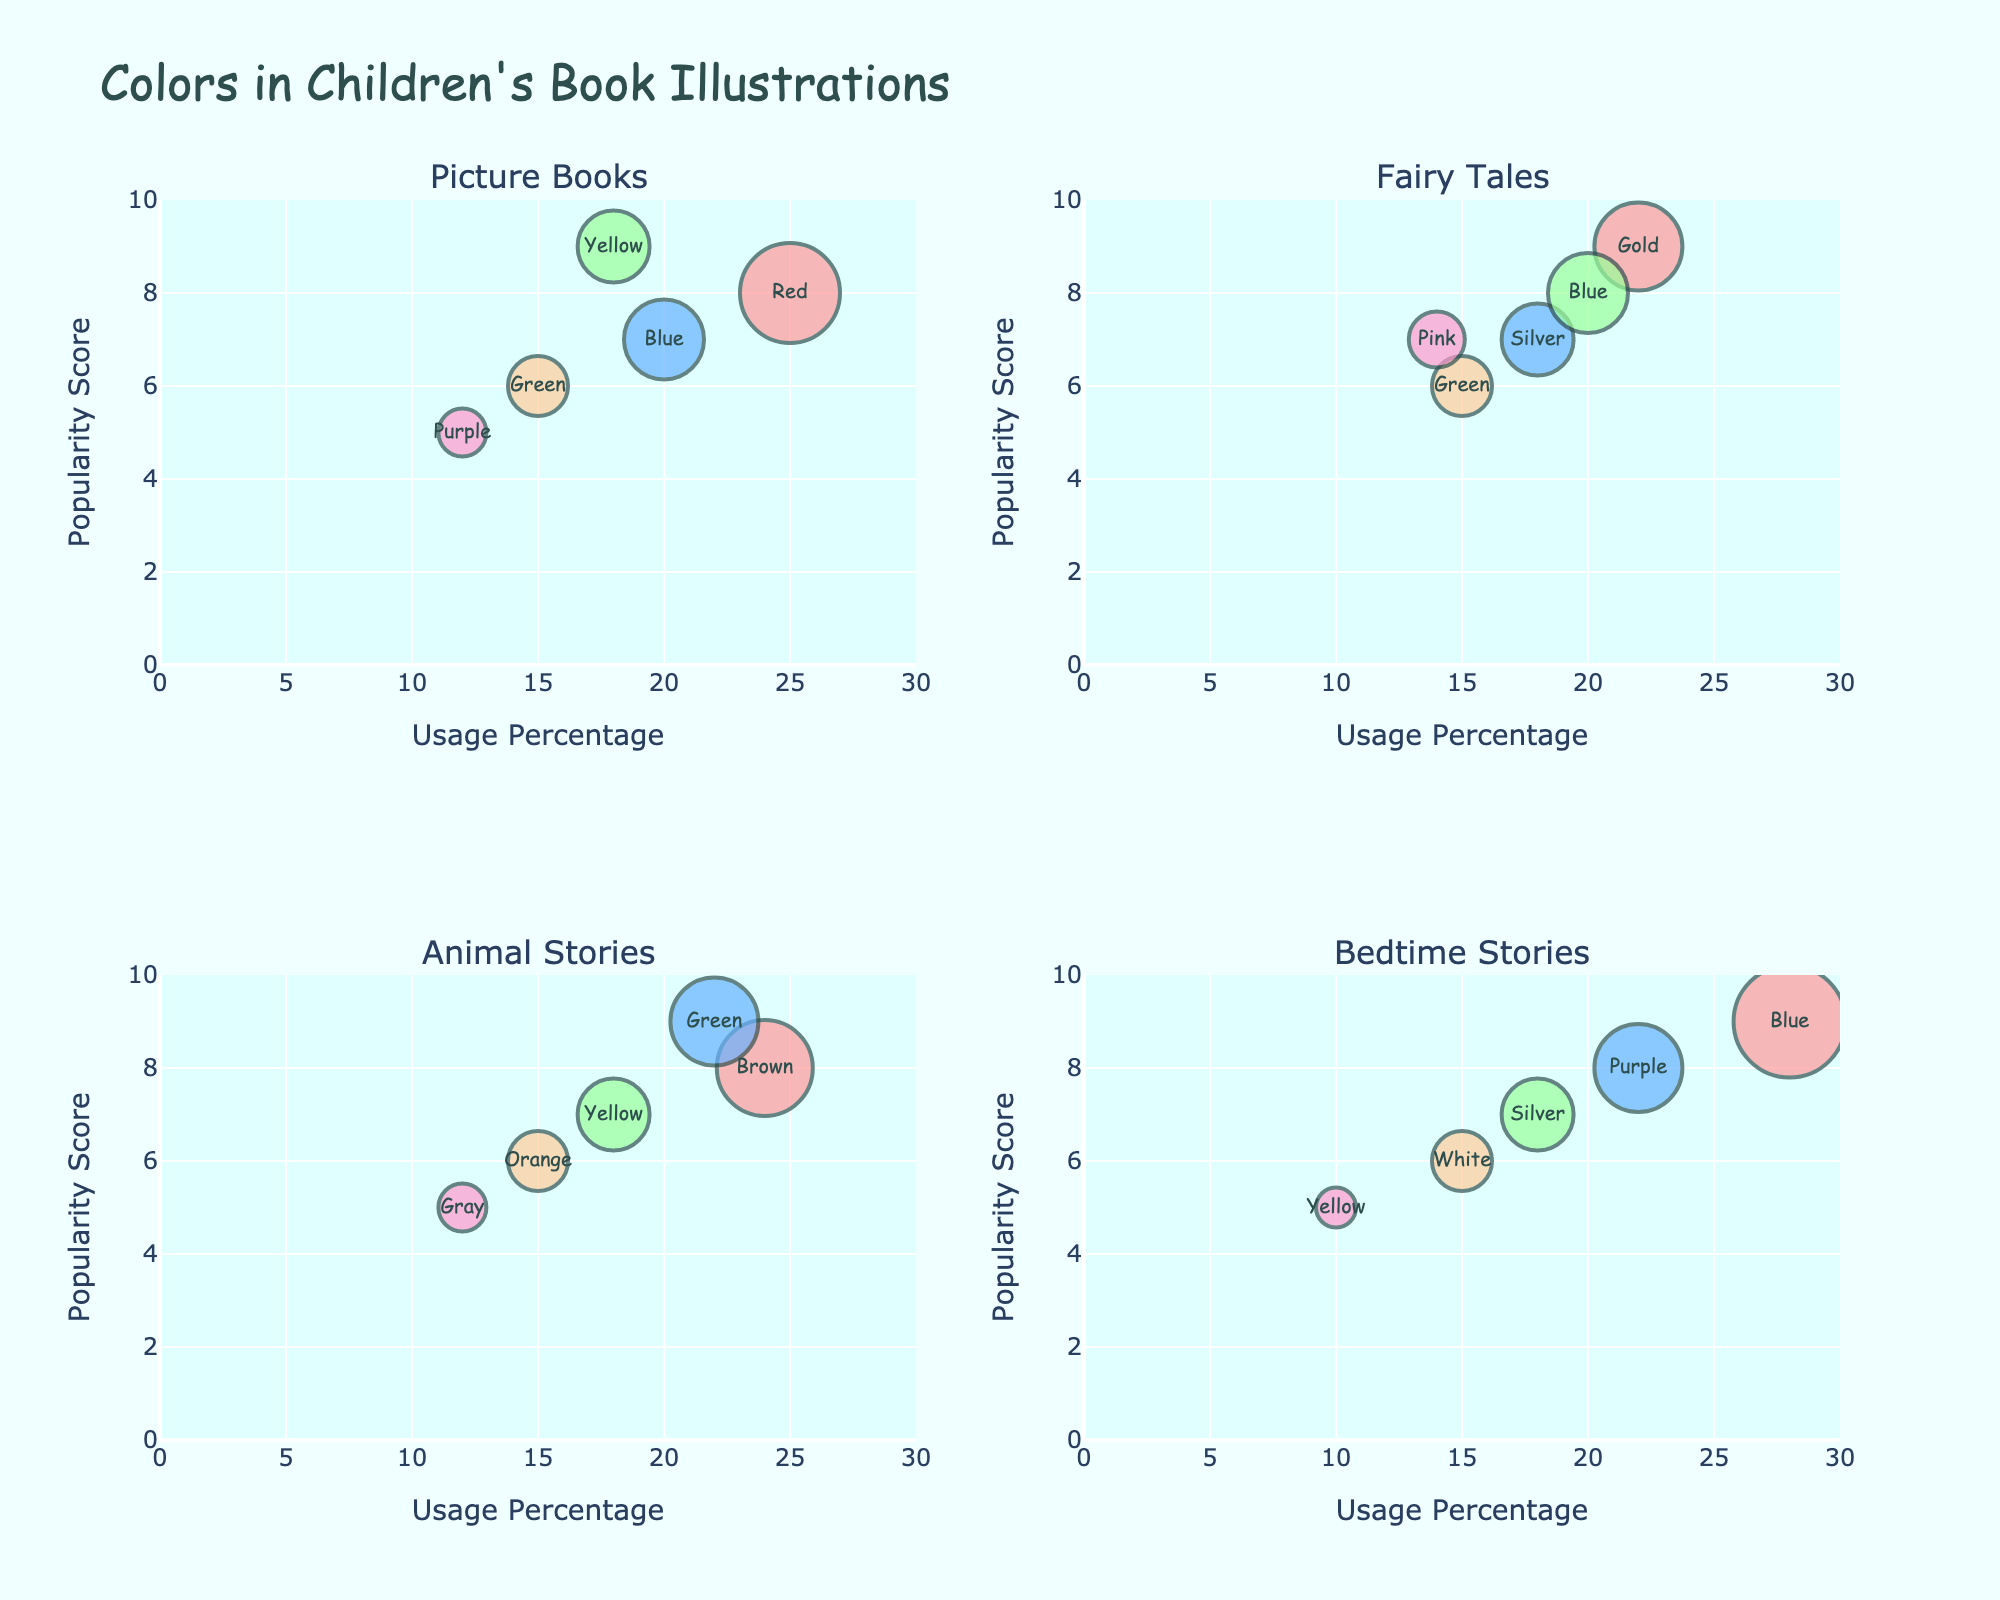what is the title of the figure? The title of the figure is located at the top. It reads "Bioavailability: Nanoparticle vs Traditional Formulations".
Answer: Bioavailability: Nanoparticle vs Traditional Formulations What organ showed the greatest difference between nanoparticle and traditional formulations at the 48-hour mark? To find the greatest difference, we subtract the bioavailability values of the traditional formulation from the nanoparticle formulation for each organ. The organ with the largest difference is chosen. For Liver = 83.2 - 42.1 = 41.1, for Kidney = 63.8 - 33.2 = 30.6, for Brain = 20.7 - 5.2 = 15.5, for Lung = 52.9 - 24.1 = 28.8.
Answer: Liver At what time point does the brain show a bioavailability value greater than 20% for the nanoparticle-based formulation? We look at the Brain_Nano values over time. At 72 hours Brain_Nano = 21.1, which is greater than 20%.
Answer: 72 hours How does the bioavailability of the kidney nanoparticle formulation at 24 hours compare to the liver traditional formulation at the same time point? From the plot, Kidney_Nano at 24 hours is 61.3, and Liver_Trad at 24 hours is 39.7. Hence, Kidney_Nano has a higher bioavailability at this time.
Answer: Kidney nanoparticle is higher What is the average bioavailability in the lung for the traditional formulation over the time course? To find the average, sum the Lung_Trad values and divide by the number of time points: (0 + 4.2 + 7.9 + 12.5 + 16.8 + 20.1 + 22.6 + 24.1 + 24.5) / 9 = 15.3%.
Answer: 15.3% Which organ showed the least bioavailability improvement when using the nanoparticle-based formulation compared to the traditional formulation at 12 hours? To determine the least improvement, calculate the difference for each organ at 12 hours: Liver = 71.8 - 35.2 = 36.6, Kidney = 56.1 - 27.9 = 28.2, Brain = 16.5 - 4.1 = 12.4, Lung = 45.7 - 20.1 = 25.6. Brain shows the least improvement.
Answer: Brain Is there a specific moment when the bioavailability of the traditional formulation plateaus, and if so, for which organs? Searching for periods where the bioavailability values remain relatively constant for the traditional formulations. For Liver_Trad, Kidney_Trad, Brain_Trad, and Lung_Trad, the data shows plateaus from 48 hours to 72 hours with minimal changes.
Answer: All organs At 8 hours, which organ has the highest bioavailability with nanoparticle formulation? By checking the values for each organ at 8 hours for the nanoparticle formulation: Liver_Nano = 62.3, Kidney_Nano = 48.5, Brain_Nano = 12.9, Lung_Nano = 39.1. Liver has the highest value.
Answer: Liver 